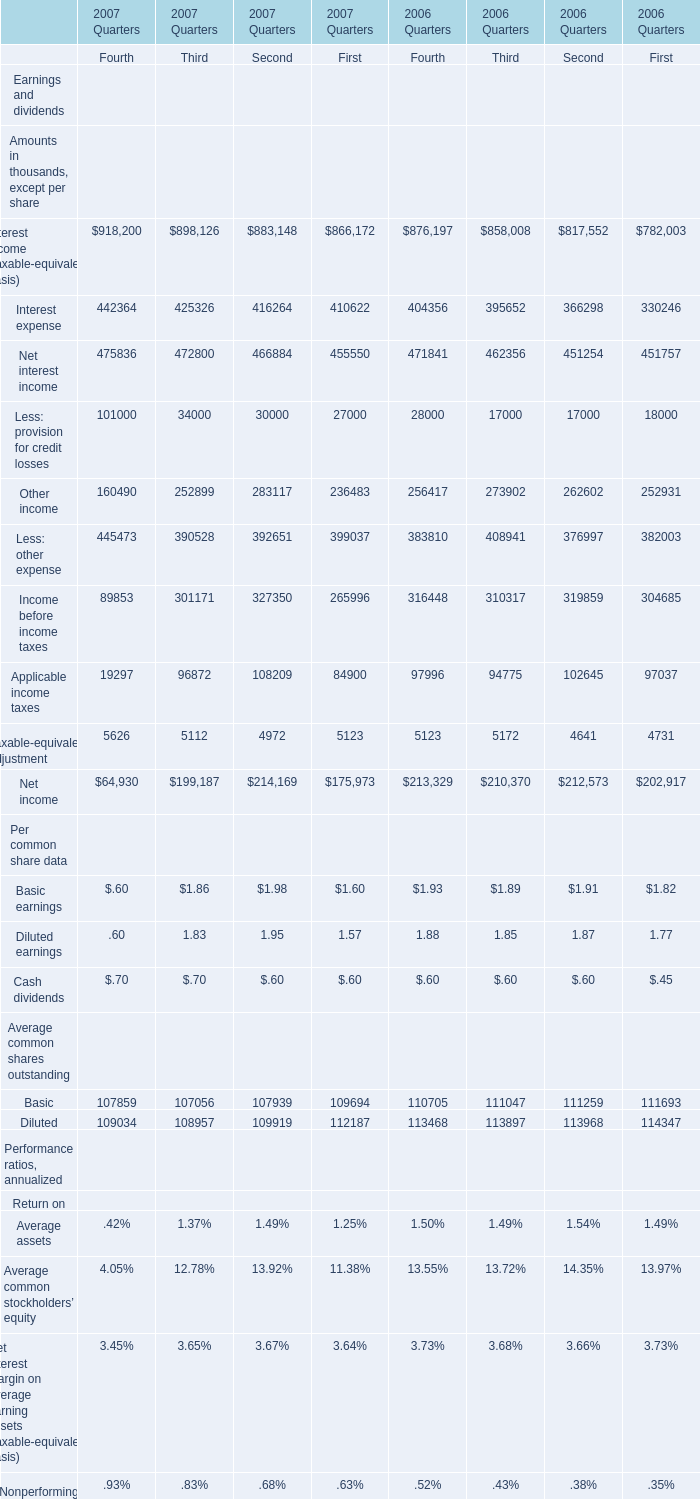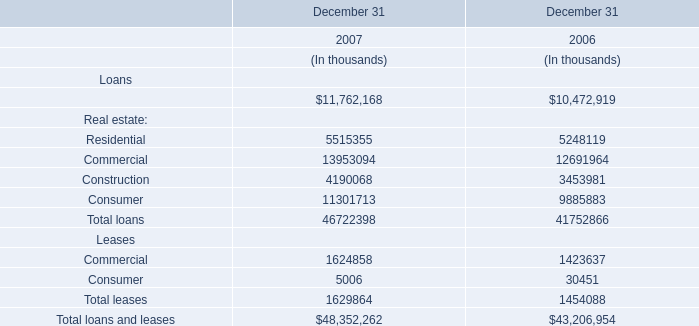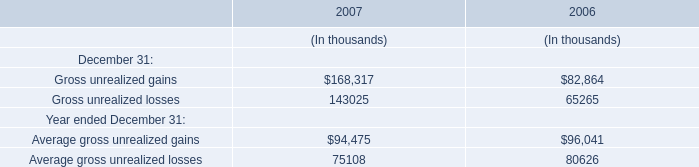What's the sum of the Basic for Average common shares outstanding in the year where Gross unrealized gains is greater than 100000? (in thousand) 
Computations: (((107859 + 107056) + 107939) + 109694)
Answer: 432548.0. 